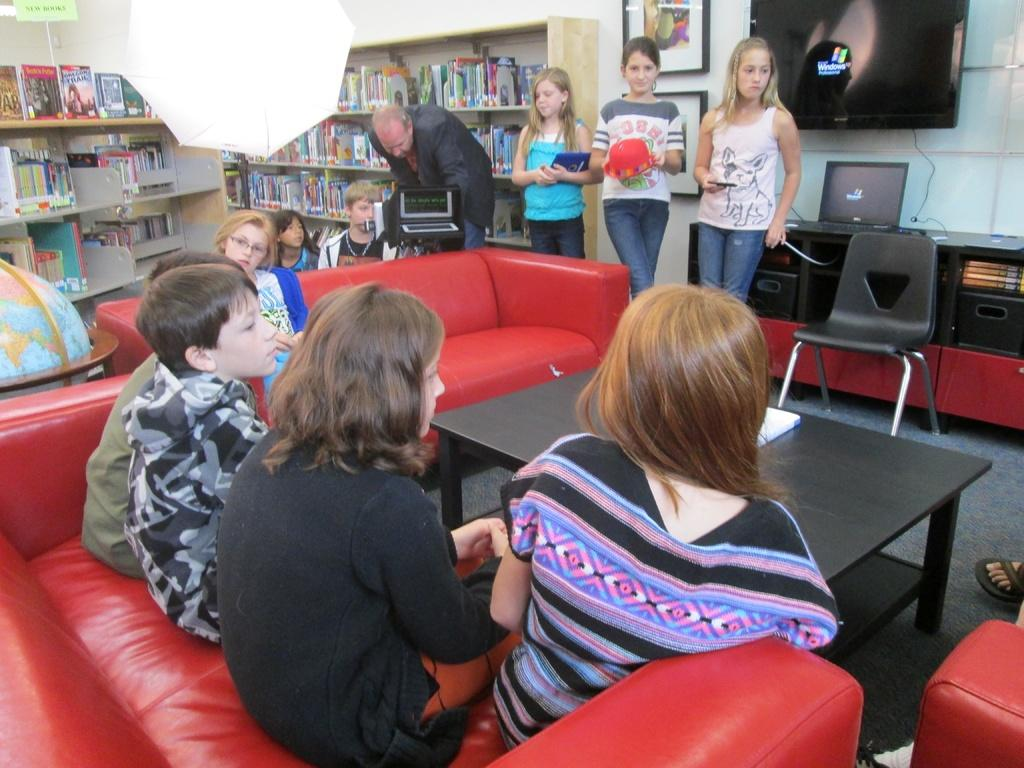<image>
Provide a brief description of the given image. A group of people meeting in a library where the shelf of books on the far wall has a book with the word Trail in it. 